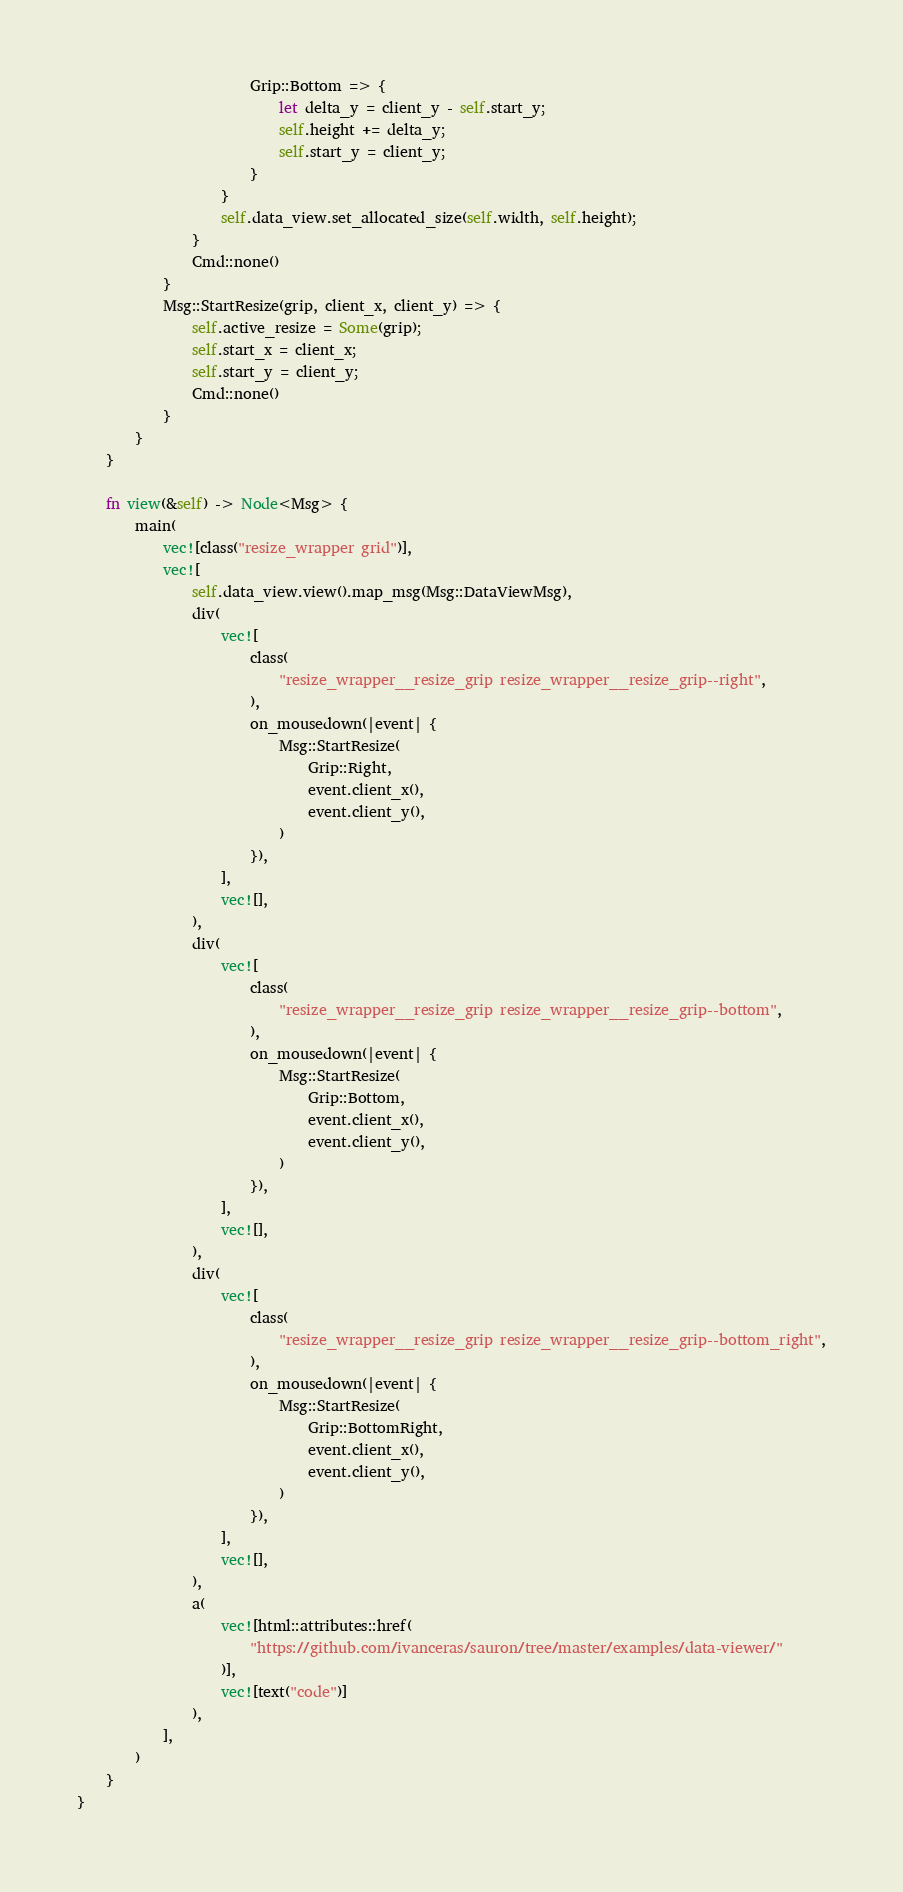Convert code to text. <code><loc_0><loc_0><loc_500><loc_500><_Rust_>                        Grip::Bottom => {
                            let delta_y = client_y - self.start_y;
                            self.height += delta_y;
                            self.start_y = client_y;
                        }
                    }
                    self.data_view.set_allocated_size(self.width, self.height);
                }
                Cmd::none()
            }
            Msg::StartResize(grip, client_x, client_y) => {
                self.active_resize = Some(grip);
                self.start_x = client_x;
                self.start_y = client_y;
                Cmd::none()
            }
        }
    }

    fn view(&self) -> Node<Msg> {
        main(
            vec![class("resize_wrapper grid")],
            vec![
                self.data_view.view().map_msg(Msg::DataViewMsg),
                div(
                    vec![
                        class(
                            "resize_wrapper__resize_grip resize_wrapper__resize_grip--right",
                        ),
                        on_mousedown(|event| {
                            Msg::StartResize(
                                Grip::Right,
                                event.client_x(),
                                event.client_y(),
                            )
                        }),
                    ],
                    vec![],
                ),
                div(
                    vec![
                        class(
                            "resize_wrapper__resize_grip resize_wrapper__resize_grip--bottom",
                        ),
                        on_mousedown(|event| {
                            Msg::StartResize(
                                Grip::Bottom,
                                event.client_x(),
                                event.client_y(),
                            )
                        }),
                    ],
                    vec![],
                ),
                div(
                    vec![
                        class(
                            "resize_wrapper__resize_grip resize_wrapper__resize_grip--bottom_right",
                        ),
                        on_mousedown(|event| {
                            Msg::StartResize(
                                Grip::BottomRight,
                                event.client_x(),
                                event.client_y(),
                            )
                        }),
                    ],
                    vec![],
                ),
                a(
                    vec![html::attributes::href(
                        "https://github.com/ivanceras/sauron/tree/master/examples/data-viewer/"
                    )],
                    vec![text("code")]
                ),
            ],
        )
    }
}
</code> 